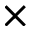<formula> <loc_0><loc_0><loc_500><loc_500>\times</formula> 